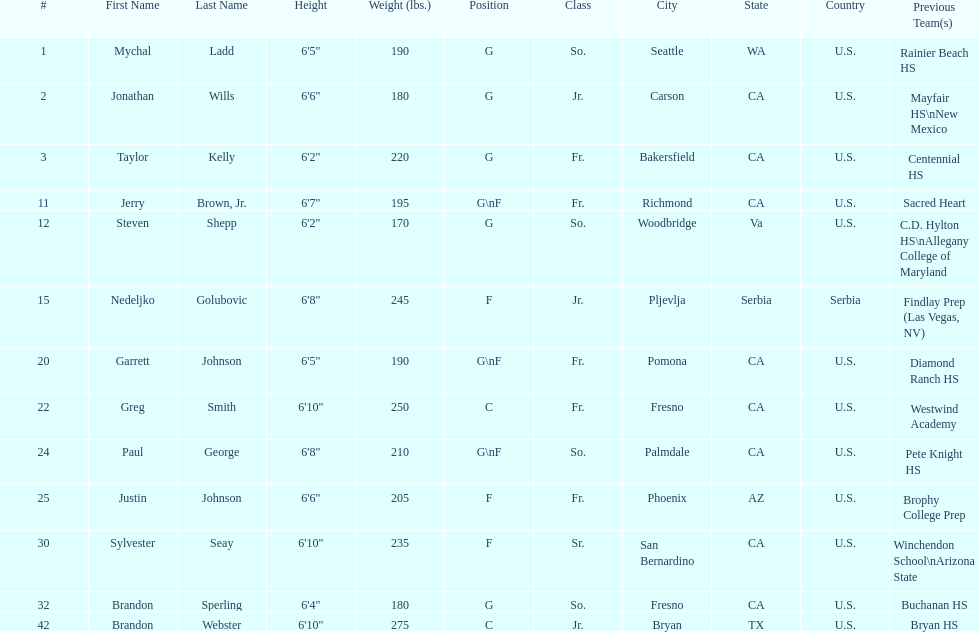Who is the next heaviest player after nedelijko golubovic? Sylvester Seay. 